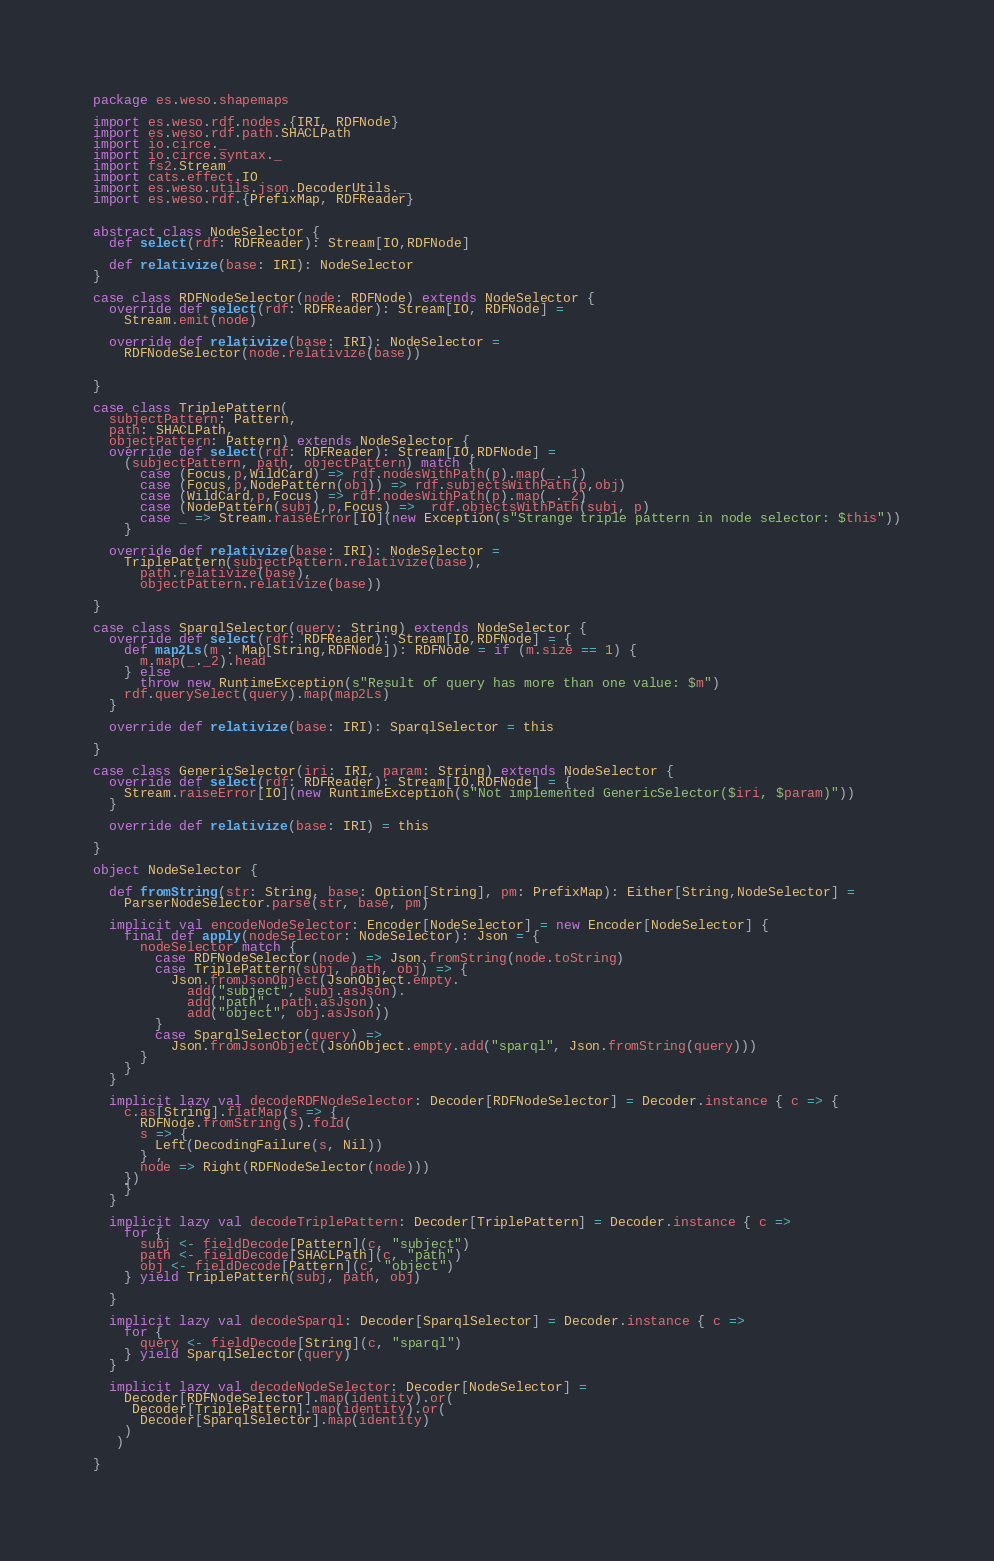<code> <loc_0><loc_0><loc_500><loc_500><_Scala_>package es.weso.shapemaps

import es.weso.rdf.nodes.{IRI, RDFNode}
import es.weso.rdf.path.SHACLPath
import io.circe._
import io.circe.syntax._
import fs2.Stream
import cats.effect.IO
import es.weso.utils.json.DecoderUtils._
import es.weso.rdf.{PrefixMap, RDFReader}


abstract class NodeSelector {
  def select(rdf: RDFReader): Stream[IO,RDFNode]

  def relativize(base: IRI): NodeSelector
}

case class RDFNodeSelector(node: RDFNode) extends NodeSelector {
  override def select(rdf: RDFReader): Stream[IO, RDFNode] =
    Stream.emit(node)

  override def relativize(base: IRI): NodeSelector =
    RDFNodeSelector(node.relativize(base))


}

case class TriplePattern(
  subjectPattern: Pattern,
  path: SHACLPath,
  objectPattern: Pattern) extends NodeSelector {
  override def select(rdf: RDFReader): Stream[IO,RDFNode] =
    (subjectPattern, path, objectPattern) match {
      case (Focus,p,WildCard) => rdf.nodesWithPath(p).map(_._1)
      case (Focus,p,NodePattern(obj)) => rdf.subjectsWithPath(p,obj)
      case (WildCard,p,Focus) => rdf.nodesWithPath(p).map(_._2)
      case (NodePattern(subj),p,Focus) =>  rdf.objectsWithPath(subj, p)
      case _ => Stream.raiseError[IO](new Exception(s"Strange triple pattern in node selector: $this"))
    }

  override def relativize(base: IRI): NodeSelector =
    TriplePattern(subjectPattern.relativize(base),
      path.relativize(base),
      objectPattern.relativize(base))

}

case class SparqlSelector(query: String) extends NodeSelector {
  override def select(rdf: RDFReader): Stream[IO,RDFNode] = {
    def map2Ls(m : Map[String,RDFNode]): RDFNode = if (m.size == 1) {
      m.map(_._2).head
    } else 
      throw new RuntimeException(s"Result of query has more than one value: $m")
    rdf.querySelect(query).map(map2Ls)
  }

  override def relativize(base: IRI): SparqlSelector = this

}

case class GenericSelector(iri: IRI, param: String) extends NodeSelector {
  override def select(rdf: RDFReader): Stream[IO,RDFNode] = {
    Stream.raiseError[IO](new RuntimeException(s"Not implemented GenericSelector($iri, $param)"))
  }

  override def relativize(base: IRI) = this

}

object NodeSelector {

  def fromString(str: String, base: Option[String], pm: PrefixMap): Either[String,NodeSelector] =
    ParserNodeSelector.parse(str, base, pm)

  implicit val encodeNodeSelector: Encoder[NodeSelector] = new Encoder[NodeSelector] {
    final def apply(nodeSelector: NodeSelector): Json = {
      nodeSelector match {
        case RDFNodeSelector(node) => Json.fromString(node.toString)
        case TriplePattern(subj, path, obj) => {
          Json.fromJsonObject(JsonObject.empty.
            add("subject", subj.asJson).
            add("path", path.asJson).
            add("object", obj.asJson))
        }
        case SparqlSelector(query) =>
          Json.fromJsonObject(JsonObject.empty.add("sparql", Json.fromString(query)))
      }
    }
  }

  implicit lazy val decodeRDFNodeSelector: Decoder[RDFNodeSelector] = Decoder.instance { c => {
    c.as[String].flatMap(s => {
      RDFNode.fromString(s).fold(
      s => {
        Left(DecodingFailure(s, Nil))
      } ,
      node => Right(RDFNodeSelector(node)))
    })
    }
  }

  implicit lazy val decodeTriplePattern: Decoder[TriplePattern] = Decoder.instance { c =>
    for {
      subj <- fieldDecode[Pattern](c, "subject")
      path <- fieldDecode[SHACLPath](c, "path")
      obj <- fieldDecode[Pattern](c, "object")
    } yield TriplePattern(subj, path, obj)

  }

  implicit lazy val decodeSparql: Decoder[SparqlSelector] = Decoder.instance { c =>
    for {
      query <- fieldDecode[String](c, "sparql")
    } yield SparqlSelector(query)
  }

  implicit lazy val decodeNodeSelector: Decoder[NodeSelector] =
    Decoder[RDFNodeSelector].map(identity).or(
     Decoder[TriplePattern].map(identity).or(
      Decoder[SparqlSelector].map(identity)
    )
   )

}</code> 